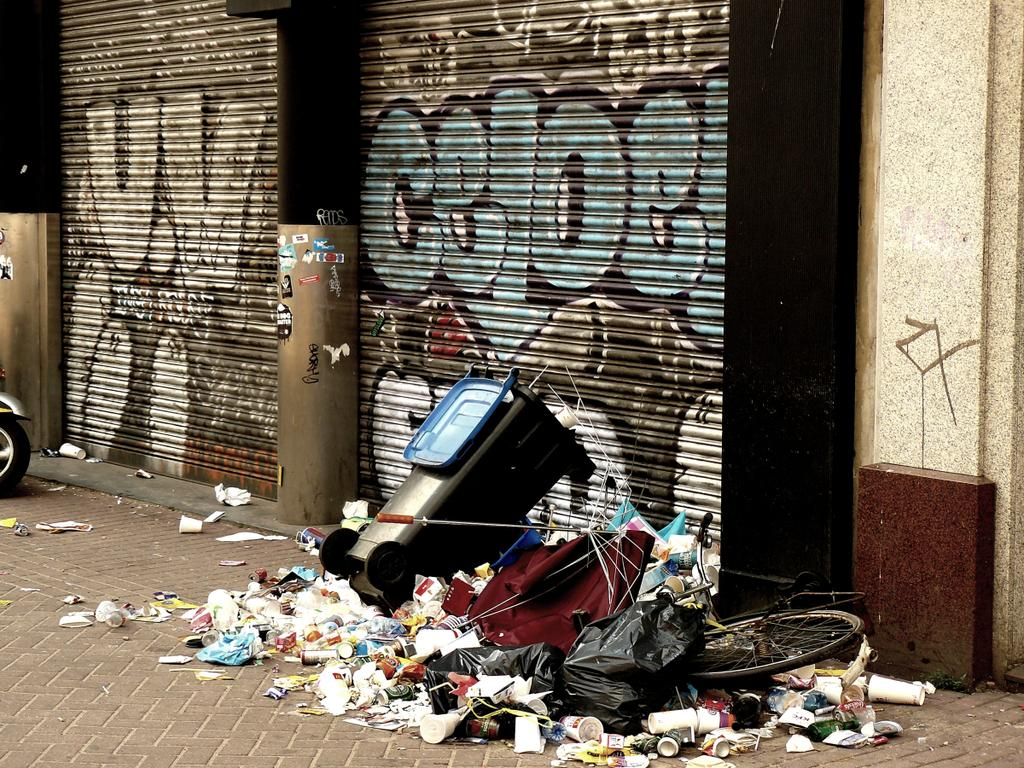<image>
Render a clear and concise summary of the photo. A wall with "U.V" graffiti on it is near a trash heap. 